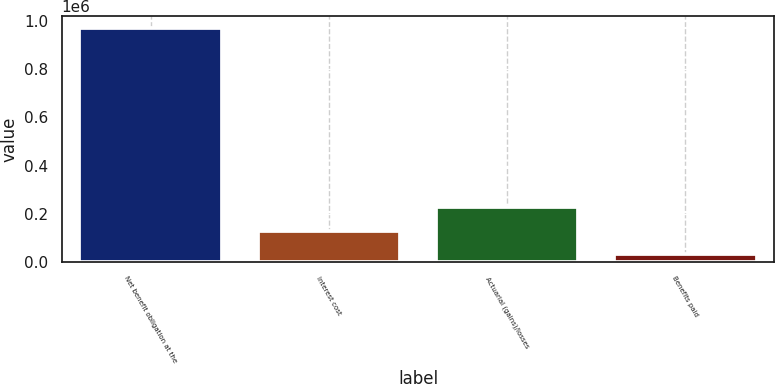<chart> <loc_0><loc_0><loc_500><loc_500><bar_chart><fcel>Net benefit obligation at the<fcel>Interest cost<fcel>Actuarial (gains)/losses<fcel>Benefits paid<nl><fcel>968938<fcel>129888<fcel>227356<fcel>32419<nl></chart> 